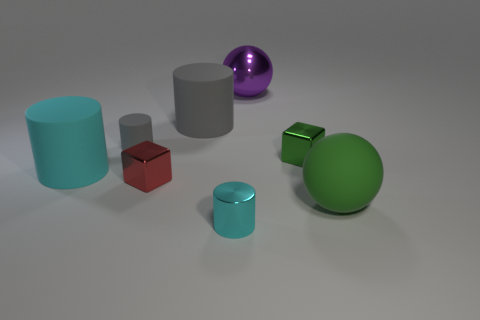Subtract all purple blocks. How many gray cylinders are left? 2 Add 1 red blocks. How many objects exist? 9 Subtract all cyan metal cylinders. How many cylinders are left? 3 Subtract all cubes. How many objects are left? 6 Subtract all brown cylinders. Subtract all gray balls. How many cylinders are left? 4 Add 5 tiny green metal cubes. How many tiny green metal cubes exist? 6 Subtract 0 blue cylinders. How many objects are left? 8 Subtract all small cyan spheres. Subtract all cyan cylinders. How many objects are left? 6 Add 7 big purple balls. How many big purple balls are left? 8 